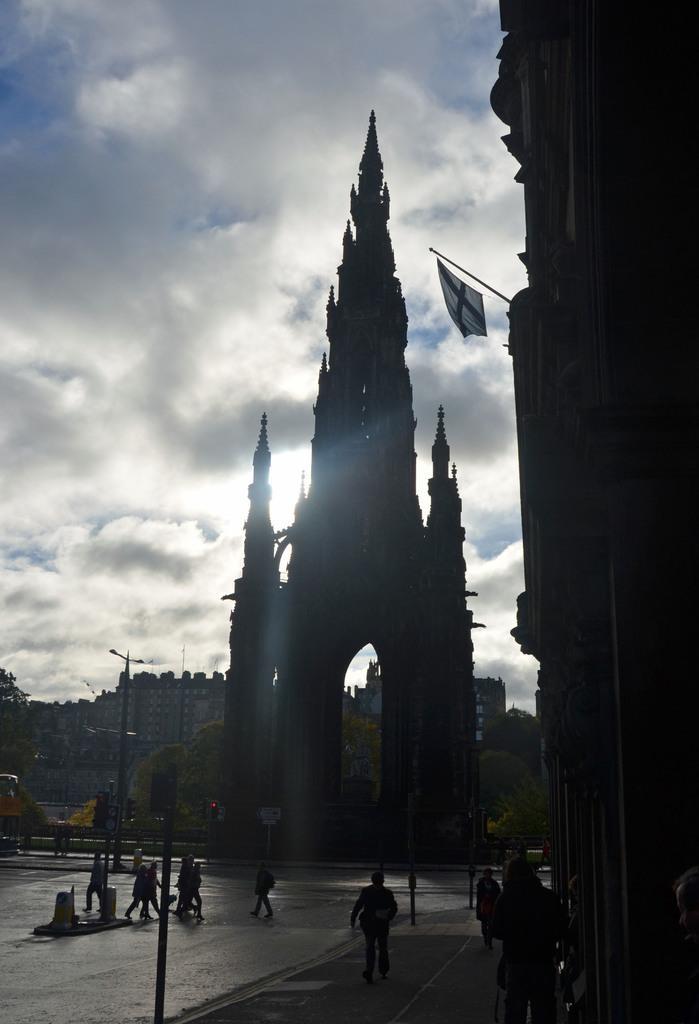Could you give a brief overview of what you see in this image? In this image, I can see the buildings, trees, few people and poles. On the right side of the image, I can see a flag hanging to a pole. In the background, there is the sky. 